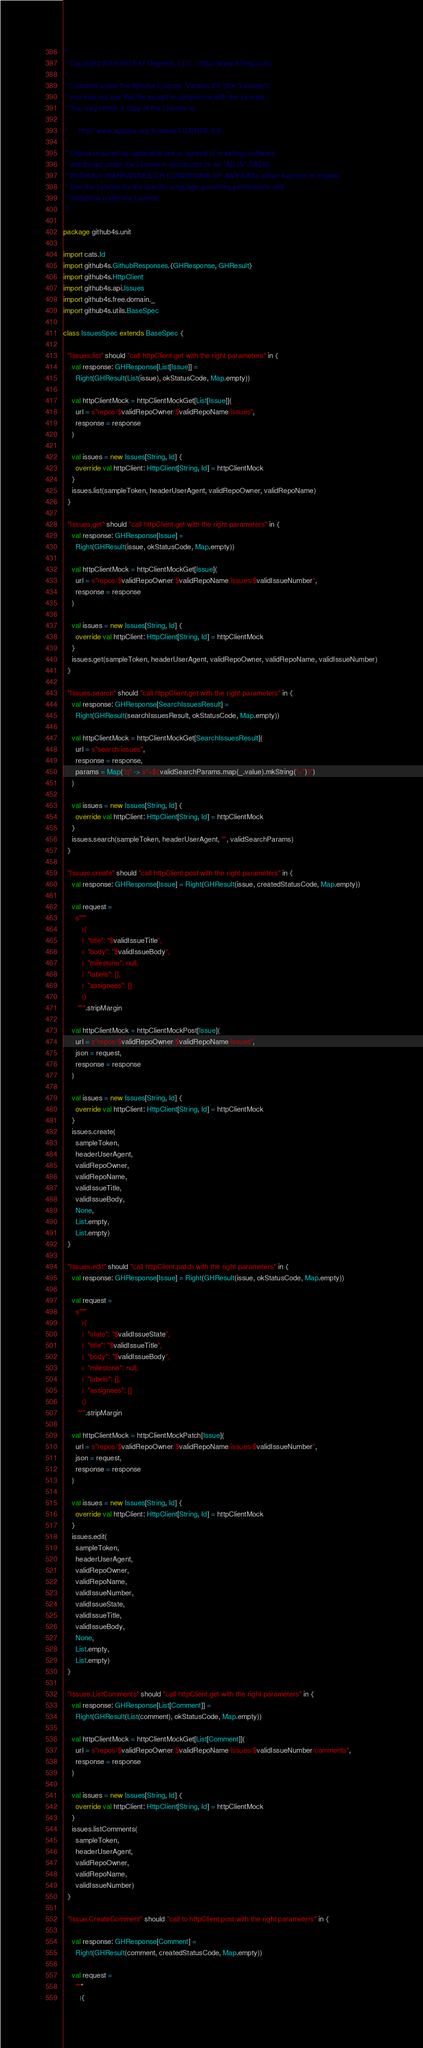<code> <loc_0><loc_0><loc_500><loc_500><_Scala_>/*
 * Copyright 2016-2019 47 Degrees, LLC. <http://www.47deg.com>
 *
 * Licensed under the Apache License, Version 2.0 (the "License");
 * you may not use this file except in compliance with the License.
 * You may obtain a copy of the License at
 *
 *     http://www.apache.org/licenses/LICENSE-2.0
 *
 * Unless required by applicable law or agreed to in writing, software
 * distributed under the License is distributed on an "AS IS" BASIS,
 * WITHOUT WARRANTIES OR CONDITIONS OF ANY KIND, either express or implied.
 * See the License for the specific language governing permissions and
 * limitations under the License.
 */

package github4s.unit

import cats.Id
import github4s.GithubResponses.{GHResponse, GHResult}
import github4s.HttpClient
import github4s.api.Issues
import github4s.free.domain._
import github4s.utils.BaseSpec

class IssuesSpec extends BaseSpec {

  "Issues.list" should "call httpClient.get with the right parameters" in {
    val response: GHResponse[List[Issue]] =
      Right(GHResult(List(issue), okStatusCode, Map.empty))

    val httpClientMock = httpClientMockGet[List[Issue]](
      url = s"repos/$validRepoOwner/$validRepoName/issues",
      response = response
    )

    val issues = new Issues[String, Id] {
      override val httpClient: HttpClient[String, Id] = httpClientMock
    }
    issues.list(sampleToken, headerUserAgent, validRepoOwner, validRepoName)
  }

  "Issues.get" should "call httpClient.get with the right parameters" in {
    val response: GHResponse[Issue] =
      Right(GHResult(issue, okStatusCode, Map.empty))

    val httpClientMock = httpClientMockGet[Issue](
      url = s"repos/$validRepoOwner/$validRepoName/issues/$validIssueNumber",
      response = response
    )

    val issues = new Issues[String, Id] {
      override val httpClient: HttpClient[String, Id] = httpClientMock
    }
    issues.get(sampleToken, headerUserAgent, validRepoOwner, validRepoName, validIssueNumber)
  }

  "Issues.search" should "call htppClient.get with the right parameters" in {
    val response: GHResponse[SearchIssuesResult] =
      Right(GHResult(searchIssuesResult, okStatusCode, Map.empty))

    val httpClientMock = httpClientMockGet[SearchIssuesResult](
      url = s"search/issues",
      response = response,
      params = Map("q" -> s"+${validSearchParams.map(_.value).mkString("+")}")
    )

    val issues = new Issues[String, Id] {
      override val httpClient: HttpClient[String, Id] = httpClientMock
    }
    issues.search(sampleToken, headerUserAgent, "", validSearchParams)
  }

  "Issues.create" should "call httpClient.post with the right parameters" in {
    val response: GHResponse[Issue] = Right(GHResult(issue, createdStatusCode, Map.empty))

    val request =
      s"""
         |{
         |  "title": "$validIssueTitle",
         |  "body": "$validIssueBody",
         |  "milestone": null,
         |  "labels": [],
         |  "assignees": []
         |}
       """.stripMargin

    val httpClientMock = httpClientMockPost[Issue](
      url = s"repos/$validRepoOwner/$validRepoName/issues",
      json = request,
      response = response
    )

    val issues = new Issues[String, Id] {
      override val httpClient: HttpClient[String, Id] = httpClientMock
    }
    issues.create(
      sampleToken,
      headerUserAgent,
      validRepoOwner,
      validRepoName,
      validIssueTitle,
      validIssueBody,
      None,
      List.empty,
      List.empty)
  }

  "Issues.edit" should "call httpClient.patch with the right parameters" in {
    val response: GHResponse[Issue] = Right(GHResult(issue, okStatusCode, Map.empty))

    val request =
      s"""
         |{
         |  "state": "$validIssueState",
         |  "title": "$validIssueTitle",
         |  "body": "$validIssueBody",
         |  "milestone": null,
         |  "labels": [],
         |  "assignees": []
         |}
       """.stripMargin

    val httpClientMock = httpClientMockPatch[Issue](
      url = s"repos/$validRepoOwner/$validRepoName/issues/$validIssueNumber",
      json = request,
      response = response
    )

    val issues = new Issues[String, Id] {
      override val httpClient: HttpClient[String, Id] = httpClientMock
    }
    issues.edit(
      sampleToken,
      headerUserAgent,
      validRepoOwner,
      validRepoName,
      validIssueNumber,
      validIssueState,
      validIssueTitle,
      validIssueBody,
      None,
      List.empty,
      List.empty)
  }

  "Issues.ListComments" should "call httpClient.get with the right parameters" in {
    val response: GHResponse[List[Comment]] =
      Right(GHResult(List(comment), okStatusCode, Map.empty))

    val httpClientMock = httpClientMockGet[List[Comment]](
      url = s"repos/$validRepoOwner/$validRepoName/issues/$validIssueNumber/comments",
      response = response
    )

    val issues = new Issues[String, Id] {
      override val httpClient: HttpClient[String, Id] = httpClientMock
    }
    issues.listComments(
      sampleToken,
      headerUserAgent,
      validRepoOwner,
      validRepoName,
      validIssueNumber)
  }

  "Issue.CreateComment" should "call to httpClient.post with the right parameters" in {

    val response: GHResponse[Comment] =
      Right(GHResult(comment, createdStatusCode, Map.empty))

    val request =
      """
        |{</code> 